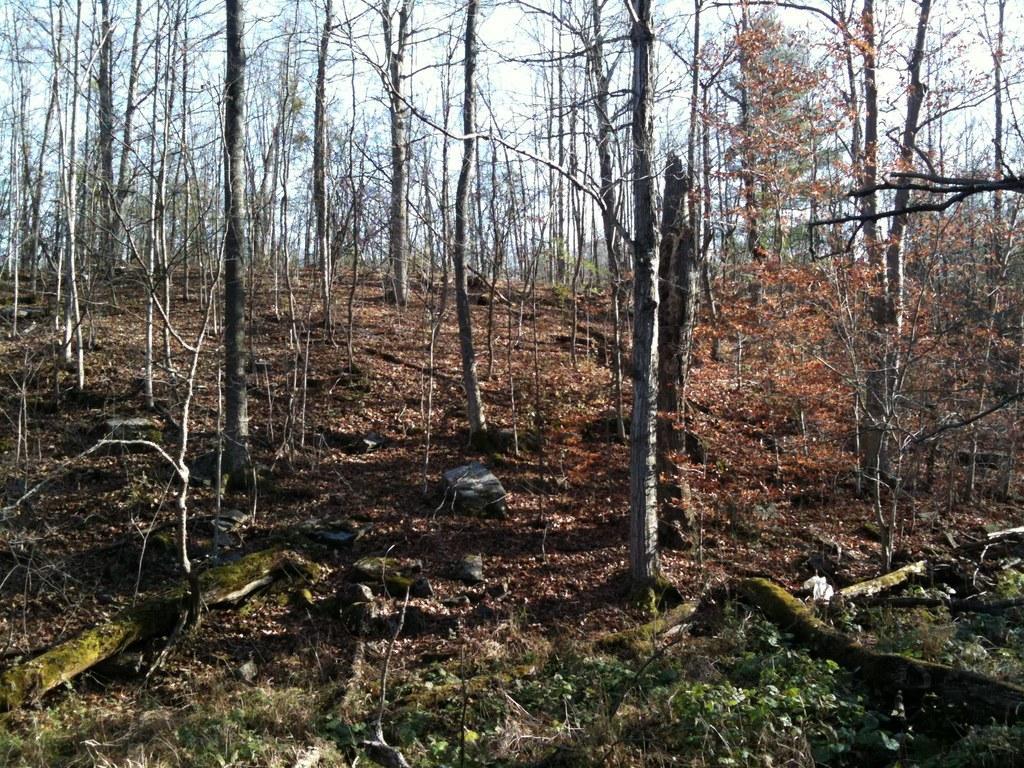What type of vegetation can be seen in the image? There are many trees, plants, and grass in the image. What is visible at the top of the image? The sky is visible at the top of the image. What color is the balloon that is floating in the sky in the image? There is no balloon present in the image; only trees, plants, grass, and the sky are visible. Can you tell me how many chess pieces are on the grass in the image? There are no chess pieces present in the image; only trees, plants, grass, and the sky are visible. 